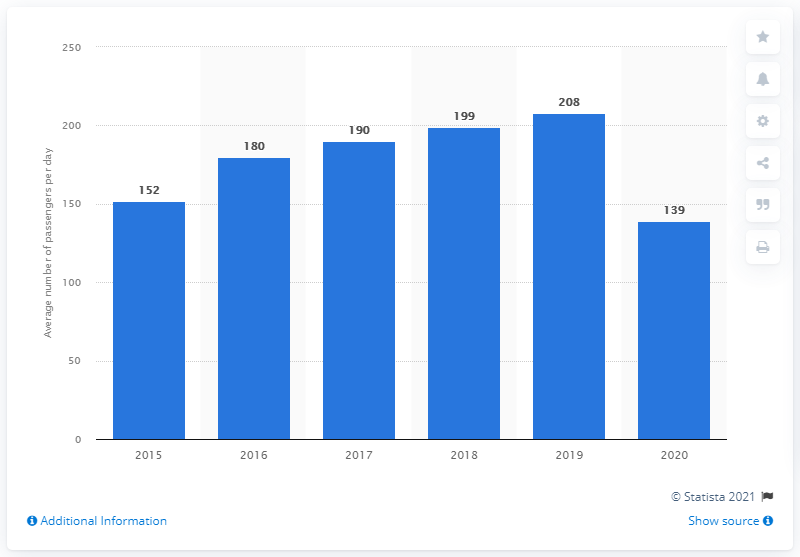Draw attention to some important aspects in this diagram. In 2020, the average passenger utilized the LRT in Singapore. 